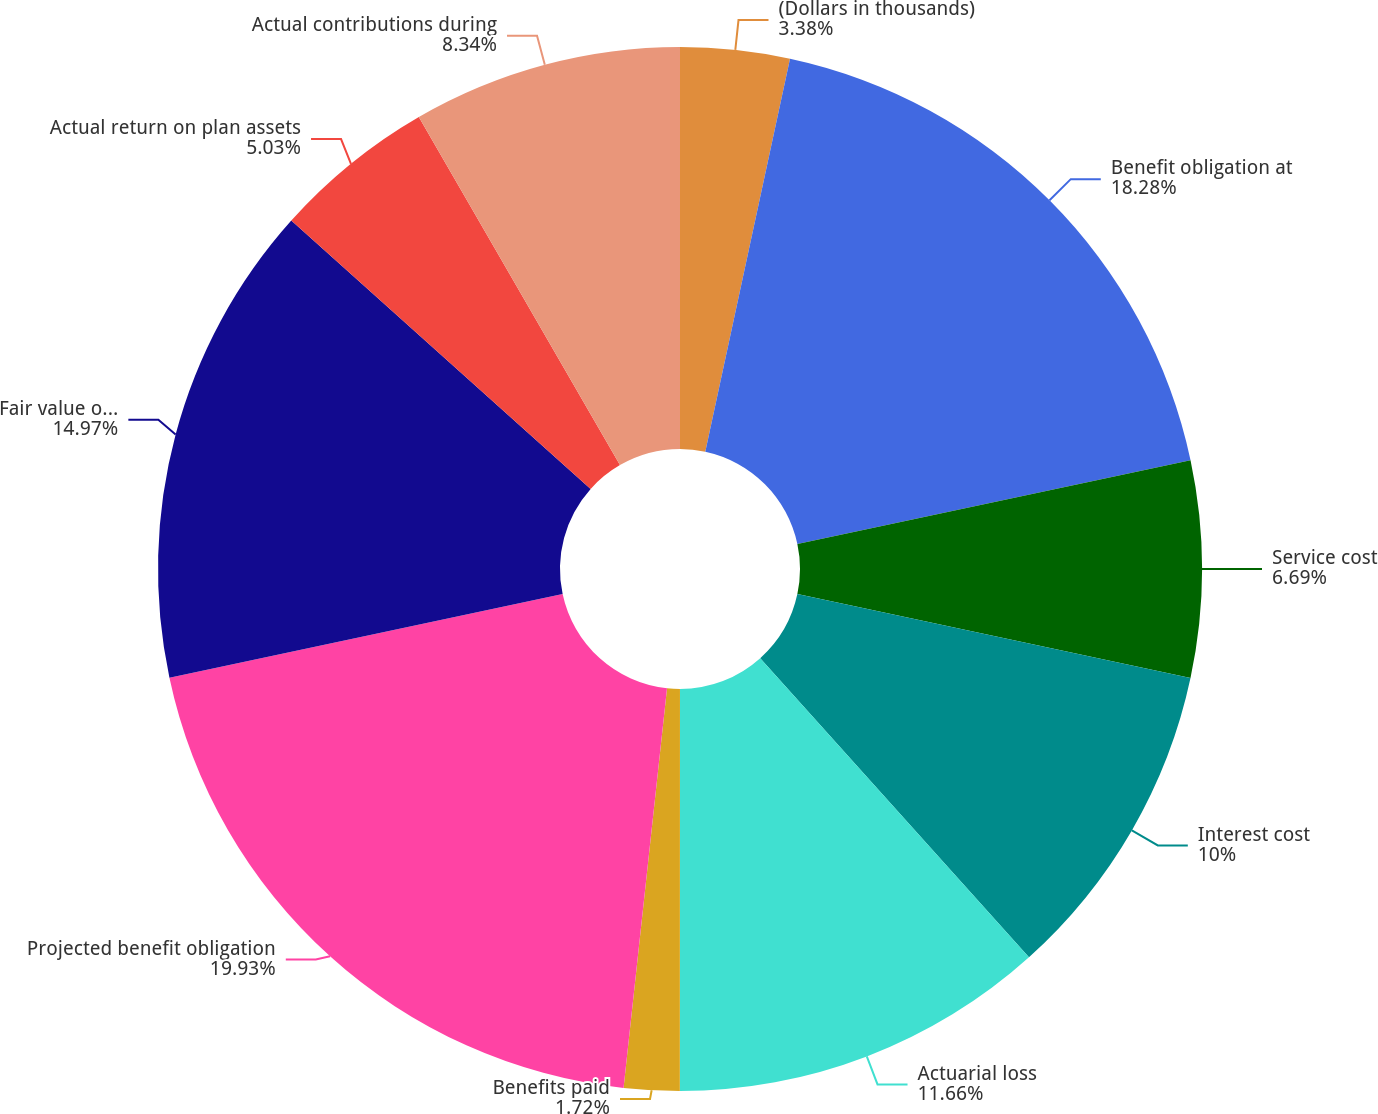Convert chart. <chart><loc_0><loc_0><loc_500><loc_500><pie_chart><fcel>(Dollars in thousands)<fcel>Benefit obligation at<fcel>Service cost<fcel>Interest cost<fcel>Actuarial loss<fcel>Benefits paid<fcel>Projected benefit obligation<fcel>Fair value of plan assets at<fcel>Actual return on plan assets<fcel>Actual contributions during<nl><fcel>3.38%<fcel>18.28%<fcel>6.69%<fcel>10.0%<fcel>11.66%<fcel>1.72%<fcel>19.94%<fcel>14.97%<fcel>5.03%<fcel>8.34%<nl></chart> 